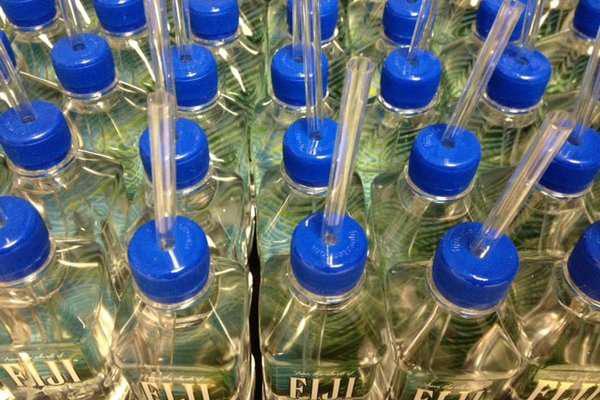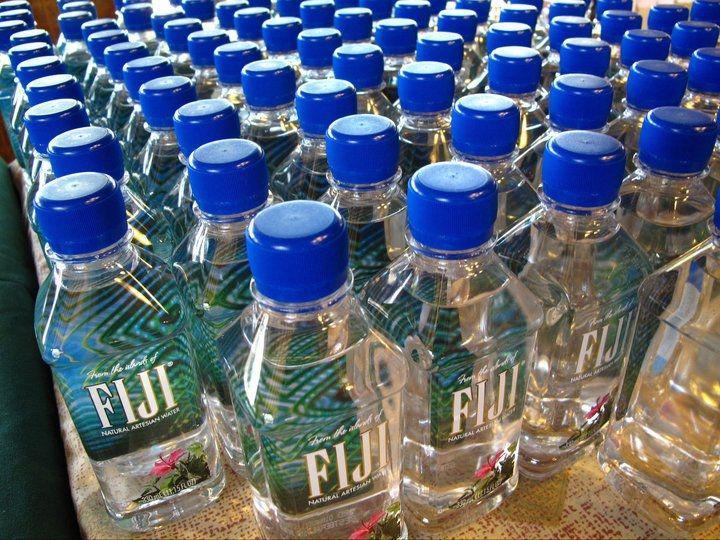The first image is the image on the left, the second image is the image on the right. Examine the images to the left and right. Is the description "At least 12 water bottles are visible in one or more images." accurate? Answer yes or no. Yes. 